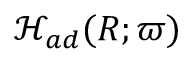Convert formula to latex. <formula><loc_0><loc_0><loc_500><loc_500>\mathcal { H } _ { a d } ( R ; \varpi )</formula> 